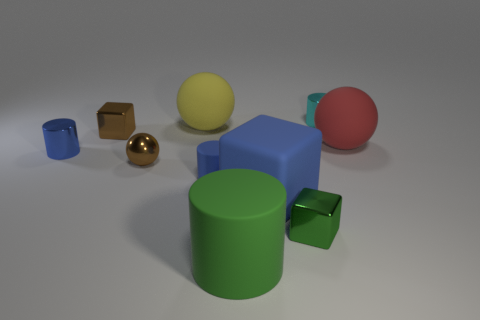Subtract all cylinders. How many objects are left? 6 Subtract all metallic blocks. Subtract all big gray cylinders. How many objects are left? 8 Add 9 large red balls. How many large red balls are left? 10 Add 4 blue cylinders. How many blue cylinders exist? 6 Subtract 0 yellow cylinders. How many objects are left? 10 